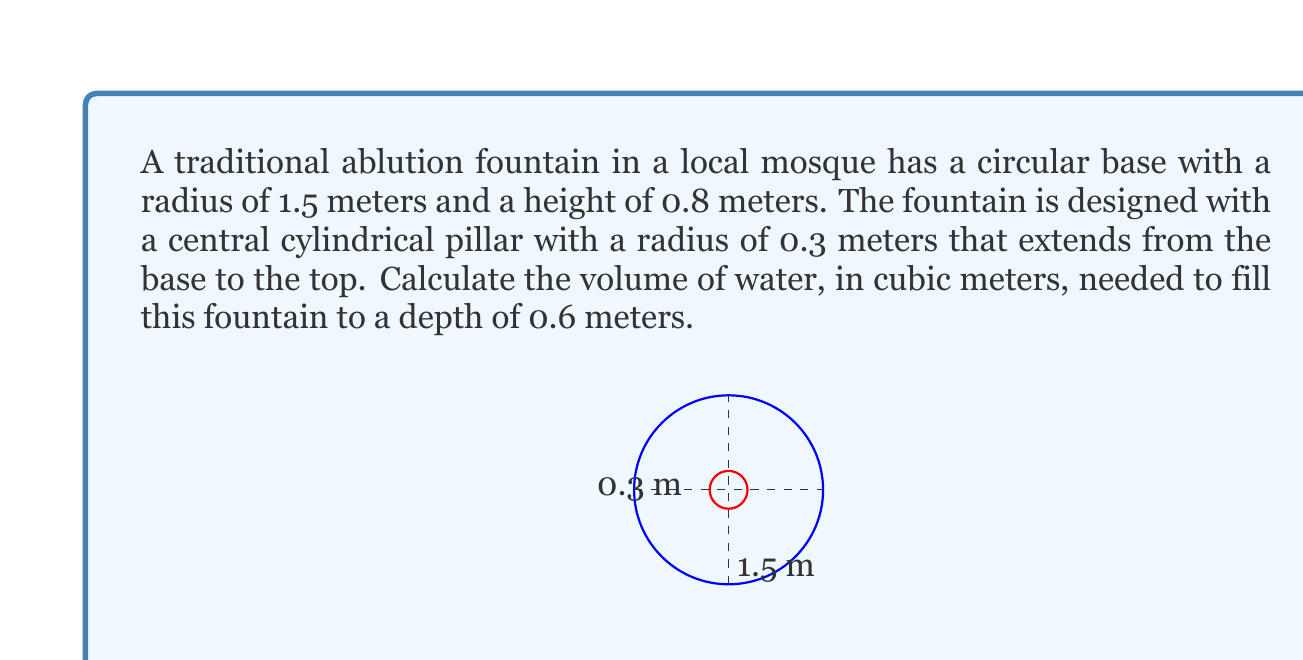Teach me how to tackle this problem. To solve this problem, we need to follow these steps:

1) First, let's identify the shapes involved:
   - The outer shape is a cylinder (the fountain)
   - The inner shape is also a cylinder (the pillar)
   - We need to find the volume of the outer cylinder minus the volume of the inner cylinder

2) The formula for the volume of a cylinder is $V = \pi r^2 h$, where $r$ is the radius and $h$ is the height.

3) For the outer cylinder:
   $r_1 = 1.5$ m, $h_1 = 0.6$ m (the depth of water)
   $V_1 = \pi (1.5)^2 (0.6) = 1.35\pi$ m³

4) For the inner cylinder:
   $r_2 = 0.3$ m, $h_2 = 0.6$ m (same as water depth)
   $V_2 = \pi (0.3)^2 (0.6) = 0.054\pi$ m³

5) The volume of water needed is the difference between these volumes:
   $V_{water} = V_1 - V_2 = 1.35\pi - 0.054\pi = 1.296\pi$ m³

6) Calculating this value:
   $V_{water} = 1.296\pi \approx 4.0715$ m³

Therefore, approximately 4.0715 cubic meters of water are needed to fill the fountain to a depth of 0.6 meters.
Answer: $4.0715$ m³ 